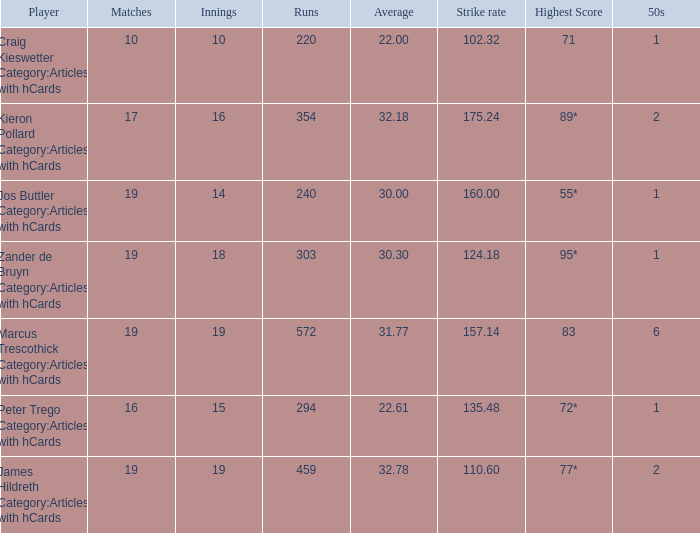What is the highest score for the player with average of 30.00? 55*. 